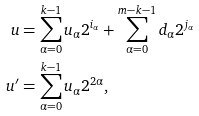<formula> <loc_0><loc_0><loc_500><loc_500>u & = \sum _ { \alpha = 0 } ^ { k - 1 } u _ { \alpha } 2 ^ { i _ { \alpha } } + \sum _ { \alpha = 0 } ^ { m - k - 1 } d _ { \alpha } 2 ^ { j _ { \alpha } } \\ u ^ { \prime } & = \sum _ { \alpha = 0 } ^ { k - 1 } u _ { \alpha } 2 ^ { 2 \alpha } ,</formula> 